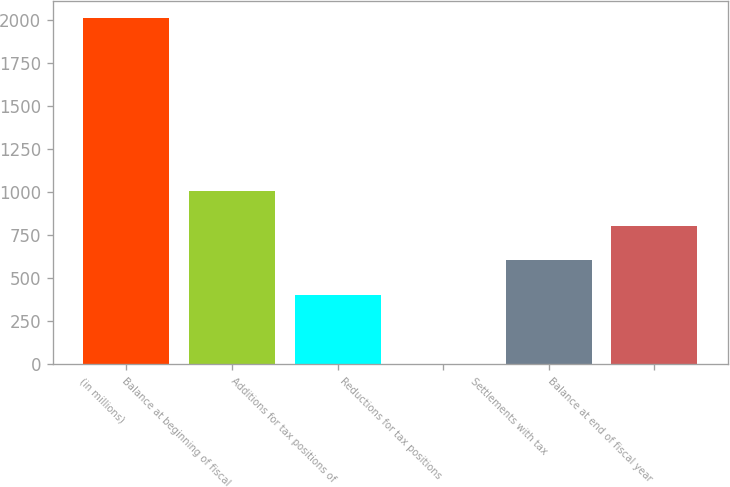Convert chart. <chart><loc_0><loc_0><loc_500><loc_500><bar_chart><fcel>(in millions)<fcel>Balance at beginning of fiscal<fcel>Additions for tax positions of<fcel>Reductions for tax positions<fcel>Settlements with tax<fcel>Balance at end of fiscal year<nl><fcel>2012<fcel>1007.5<fcel>404.8<fcel>3<fcel>605.7<fcel>806.6<nl></chart> 